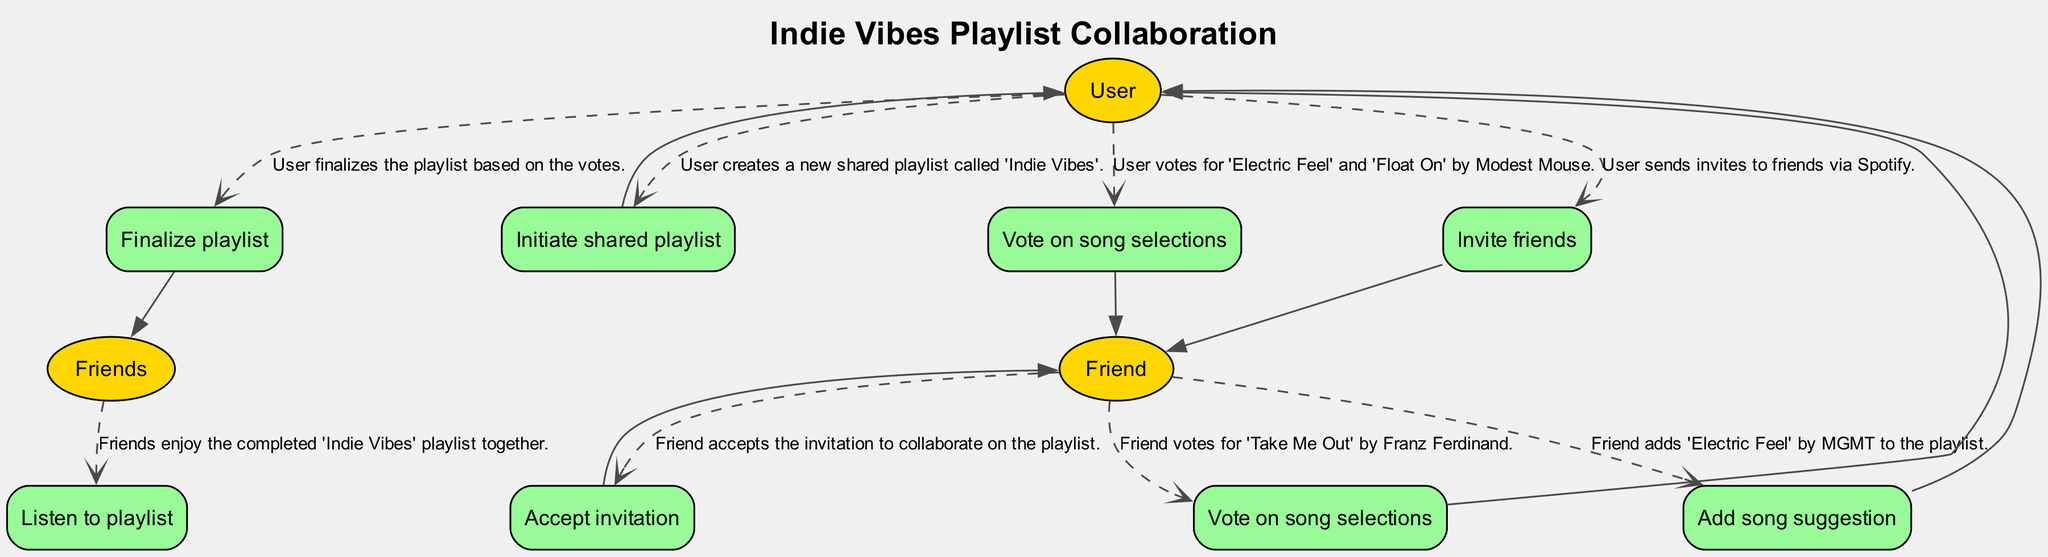What is the title of the shared playlist created by the user? The diagram indicates that the User creates a shared playlist called 'Indie Vibes' at the beginning of the sequence.
Answer: Indie Vibes How many songs did the user vote for? The diagram shows that the User voted for two songs: 'Electric Feel' and 'Float On'. Thus, the count of votes is two.
Answer: 2 What action does the friend take after accepting the invitation? According to the diagram sequence, the Friend adds a song suggestion, specifically 'Electric Feel' by MGMT, immediately after accepting the invitation.
Answer: Add song suggestion Who finalizes the playlist? The diagram indicates that the User is responsible for finalizing the playlist based on the votes received from both the User and the Friend.
Answer: User What action occurs last in the sequence? The last action in the sequence indicates that Friends listen to the completed 'Indie Vibes' playlist together, which wraps up the collaborative effort.
Answer: Listen to playlist How many actors are involved in this sequence? Examining the diagram reveals two distinct actors: the User and the Friend, who participate in the actions throughout the sequence.
Answer: 2 Which song did the Friend suggest? The diagram specifically states that the Friend added 'Electric Feel' by MGMT as their song suggestion for the playlist.
Answer: Electric Feel What happens after the user votes for the songs? According to the diagram, after the User votes for the songs, it leads to the Friend voting on their selected song as part of the collaboration process.
Answer: Friend votes What is the relationship between user voting and finalizing the playlist? The diagram outlines that the User votes on song selections before finalizing the playlist, suggesting the votes directly influence what songs are included, indicating a cause-effect relationship.
Answer: Votes influence finalization 